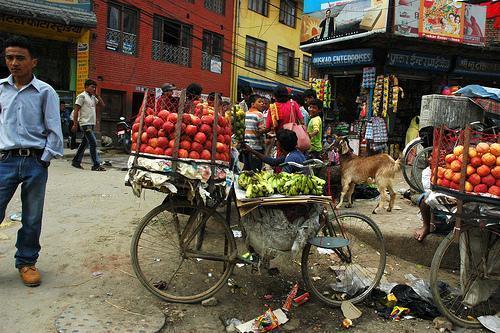How many people are wearing red shirt?
Give a very brief answer. 1. 